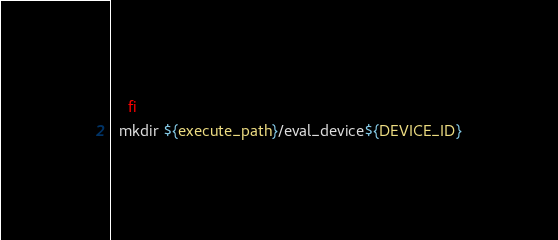<code> <loc_0><loc_0><loc_500><loc_500><_Bash_>    fi
  mkdir ${execute_path}/eval_device${DEVICE_ID}</code> 